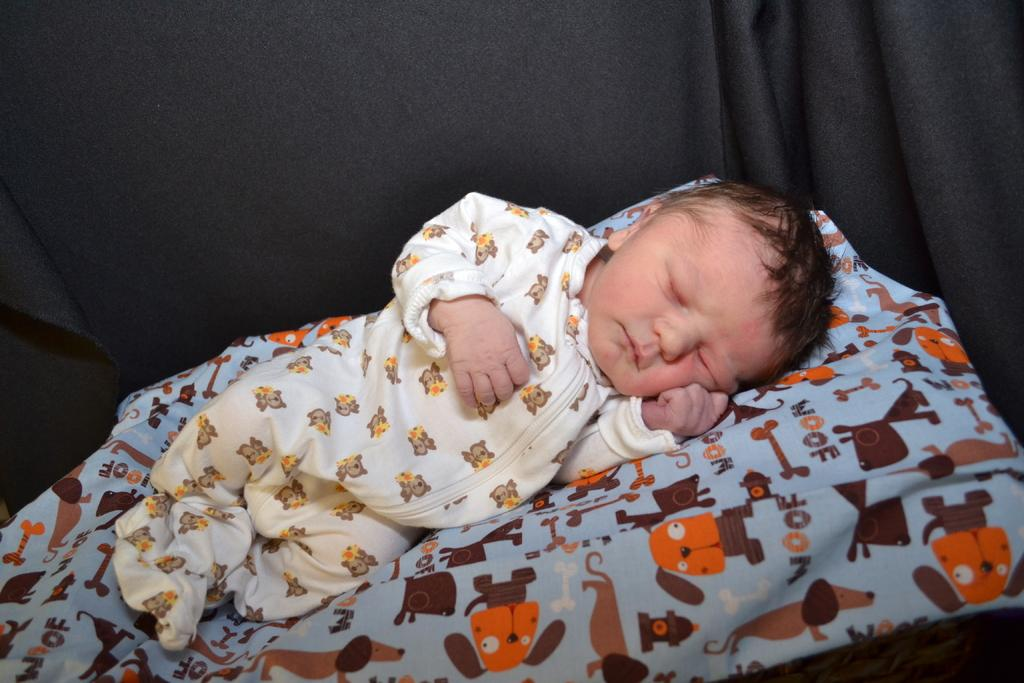What is the main subject of the image? There is a baby in the image. What is the baby doing in the image? The baby is sleeping on a bed. What can be seen in the background of the image? There is a black curtain visible in the image. What advice does the manager give to the baby in the image? There is no manager present in the image, and therefore no advice can be given. 